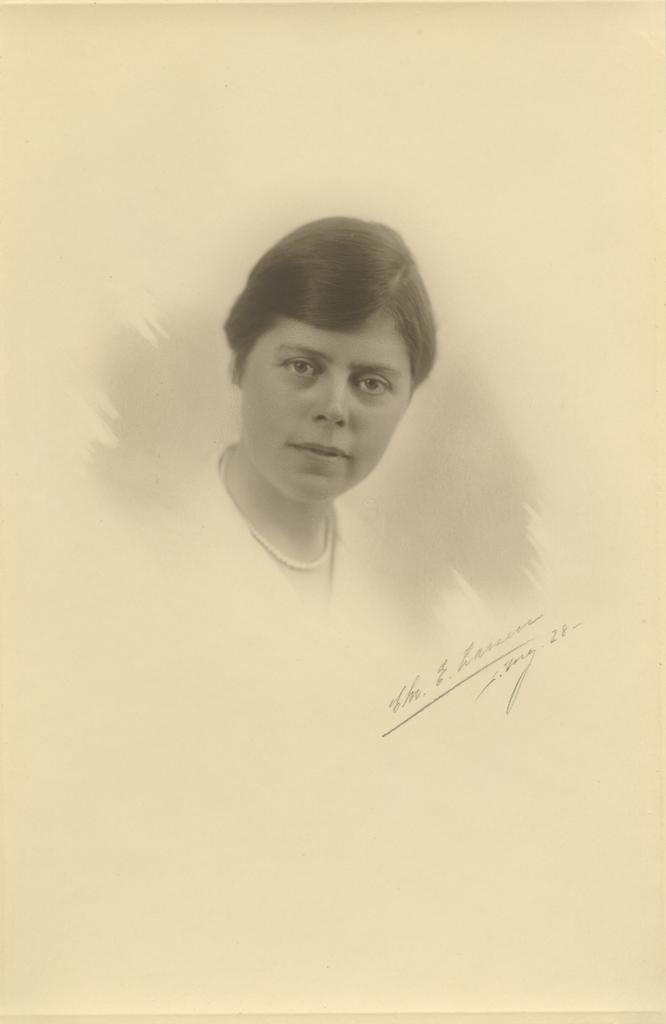What is the main subject of the image? The main subject of the image is a photo of a person. What additional detail can be observed on the photo? There is text written on the photo. How does the yak act in the image? There is no yak present in the image, so it cannot be determined how a yak might act. 